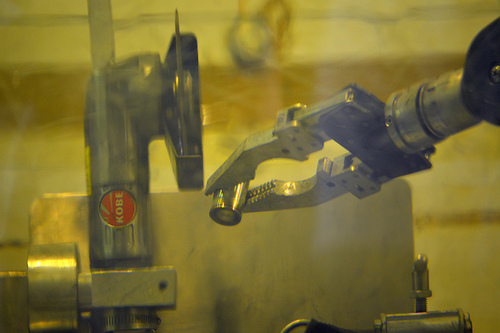<image>
Is the tool next to the tool? Yes. The tool is positioned adjacent to the tool, located nearby in the same general area. 